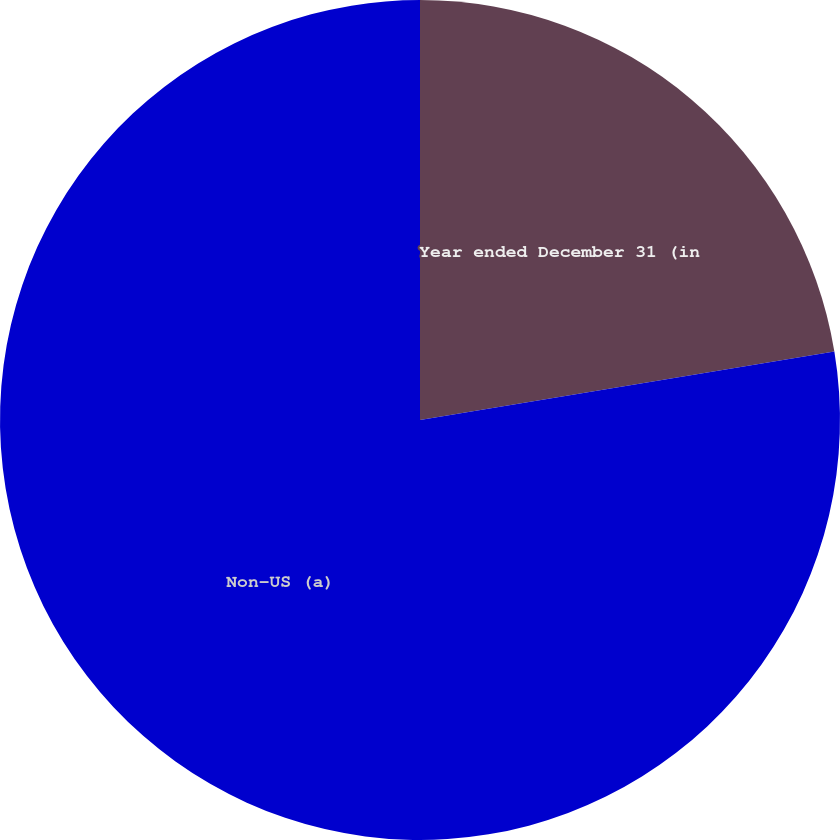Convert chart. <chart><loc_0><loc_0><loc_500><loc_500><pie_chart><fcel>Year ended December 31 (in<fcel>Non-US (a)<nl><fcel>22.39%<fcel>77.61%<nl></chart> 